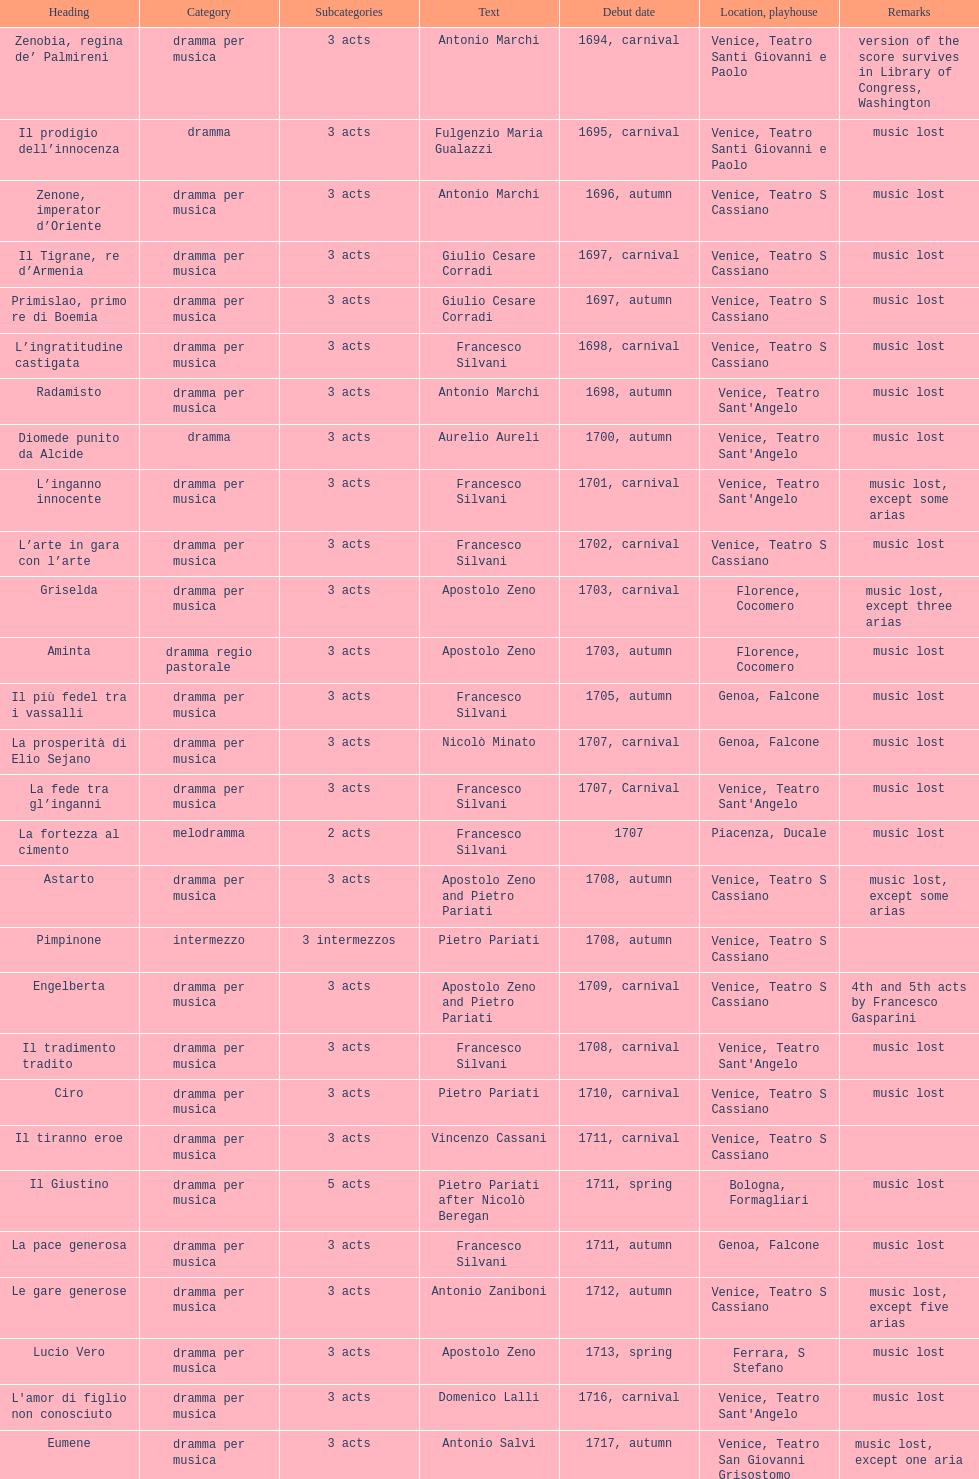Which opera has at least 5 acts? Il Giustino. 